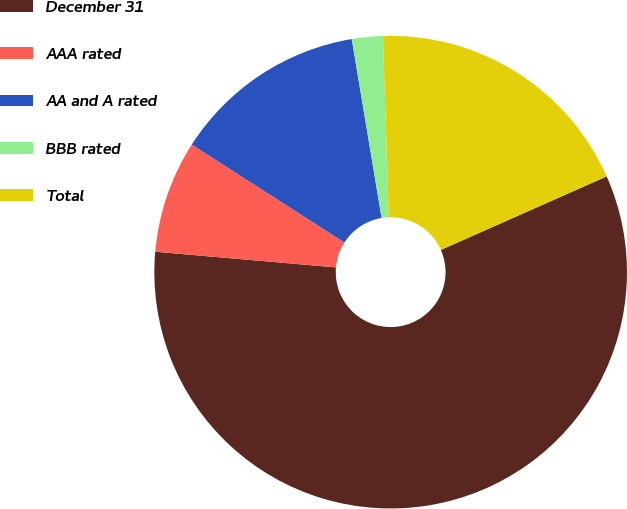<chart> <loc_0><loc_0><loc_500><loc_500><pie_chart><fcel>December 31<fcel>AAA rated<fcel>AA and A rated<fcel>BBB rated<fcel>Total<nl><fcel>58.02%<fcel>7.7%<fcel>13.29%<fcel>2.11%<fcel>18.88%<nl></chart> 